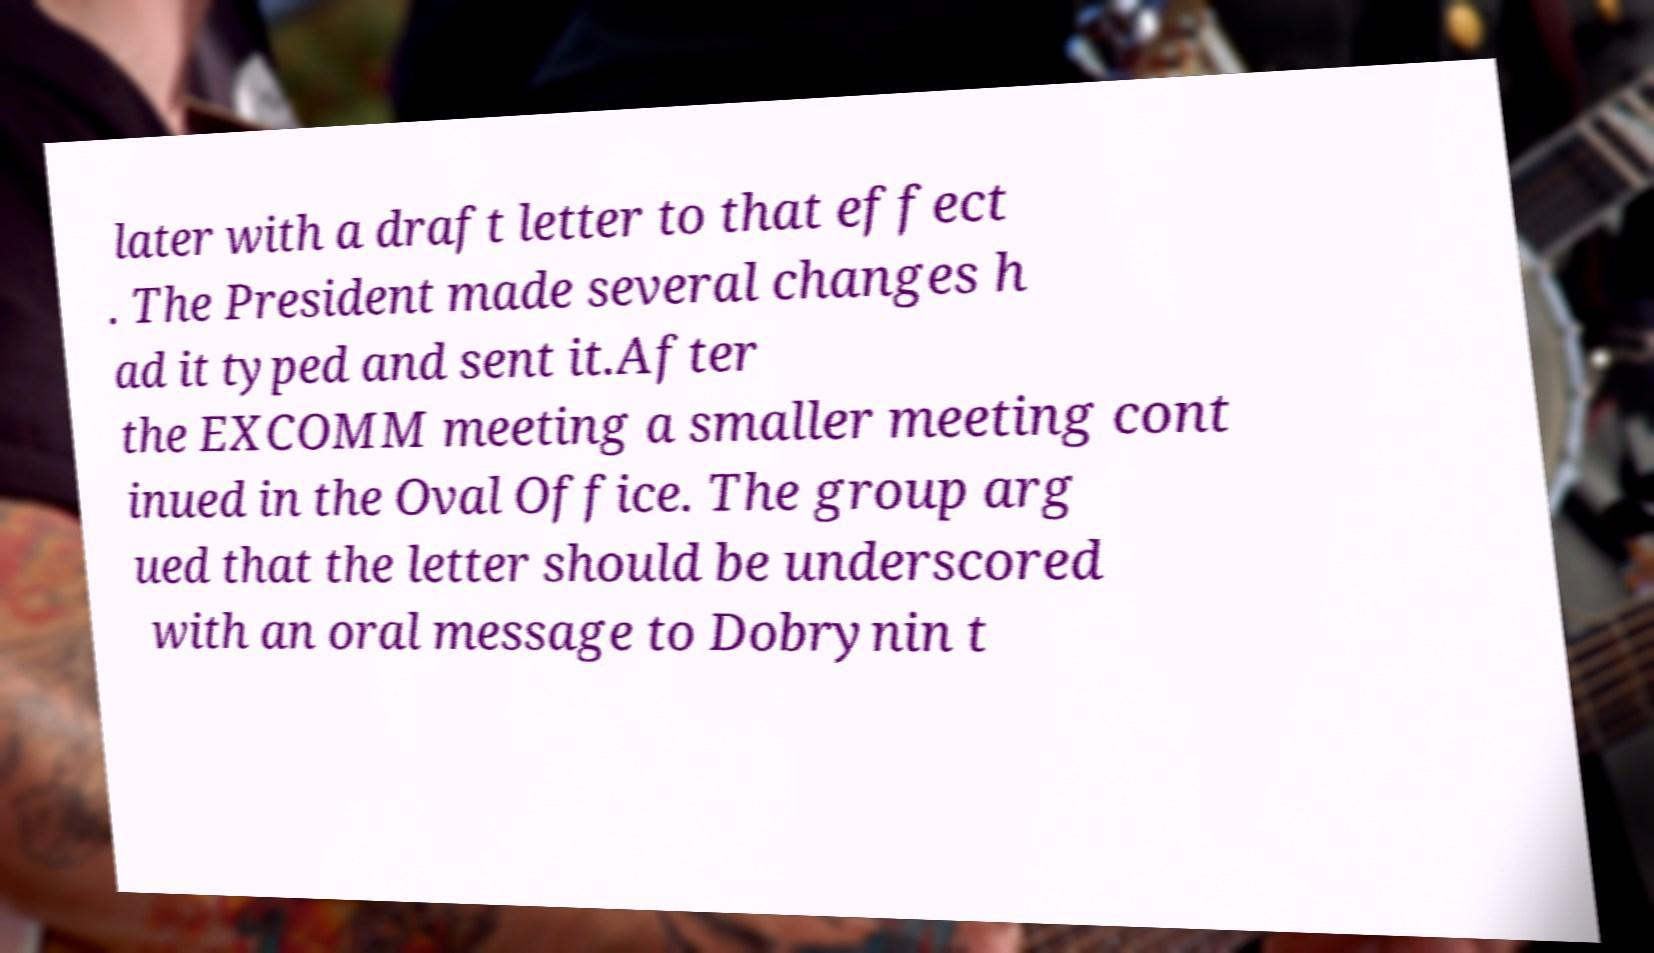I need the written content from this picture converted into text. Can you do that? later with a draft letter to that effect . The President made several changes h ad it typed and sent it.After the EXCOMM meeting a smaller meeting cont inued in the Oval Office. The group arg ued that the letter should be underscored with an oral message to Dobrynin t 